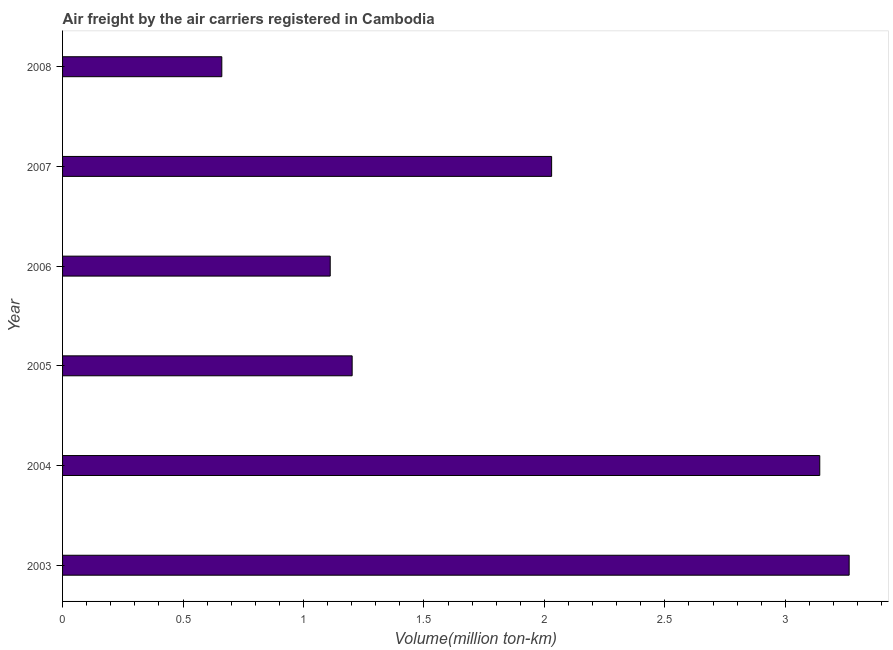Does the graph contain any zero values?
Offer a very short reply. No. What is the title of the graph?
Provide a succinct answer. Air freight by the air carriers registered in Cambodia. What is the label or title of the X-axis?
Give a very brief answer. Volume(million ton-km). What is the air freight in 2005?
Give a very brief answer. 1.2. Across all years, what is the maximum air freight?
Provide a succinct answer. 3.27. Across all years, what is the minimum air freight?
Provide a short and direct response. 0.66. In which year was the air freight maximum?
Provide a succinct answer. 2003. In which year was the air freight minimum?
Offer a terse response. 2008. What is the sum of the air freight?
Keep it short and to the point. 11.41. What is the difference between the air freight in 2003 and 2006?
Provide a short and direct response. 2.15. What is the average air freight per year?
Give a very brief answer. 1.9. What is the median air freight?
Give a very brief answer. 1.62. In how many years, is the air freight greater than 0.6 million ton-km?
Your answer should be compact. 6. Do a majority of the years between 2003 and 2006 (inclusive) have air freight greater than 0.8 million ton-km?
Your response must be concise. Yes. What is the ratio of the air freight in 2004 to that in 2005?
Give a very brief answer. 2.62. Is the air freight in 2003 less than that in 2008?
Your answer should be very brief. No. Is the difference between the air freight in 2003 and 2006 greater than the difference between any two years?
Your response must be concise. No. What is the difference between the highest and the second highest air freight?
Keep it short and to the point. 0.12. Are all the bars in the graph horizontal?
Give a very brief answer. Yes. How many years are there in the graph?
Your response must be concise. 6. What is the difference between two consecutive major ticks on the X-axis?
Provide a short and direct response. 0.5. Are the values on the major ticks of X-axis written in scientific E-notation?
Ensure brevity in your answer.  No. What is the Volume(million ton-km) in 2003?
Provide a succinct answer. 3.27. What is the Volume(million ton-km) of 2004?
Offer a very short reply. 3.14. What is the Volume(million ton-km) of 2005?
Provide a succinct answer. 1.2. What is the Volume(million ton-km) of 2006?
Give a very brief answer. 1.11. What is the Volume(million ton-km) in 2007?
Your response must be concise. 2.03. What is the Volume(million ton-km) of 2008?
Your answer should be very brief. 0.66. What is the difference between the Volume(million ton-km) in 2003 and 2004?
Make the answer very short. 0.12. What is the difference between the Volume(million ton-km) in 2003 and 2005?
Offer a very short reply. 2.06. What is the difference between the Volume(million ton-km) in 2003 and 2006?
Provide a succinct answer. 2.15. What is the difference between the Volume(million ton-km) in 2003 and 2007?
Offer a terse response. 1.24. What is the difference between the Volume(million ton-km) in 2003 and 2008?
Your answer should be very brief. 2.6. What is the difference between the Volume(million ton-km) in 2004 and 2005?
Your response must be concise. 1.94. What is the difference between the Volume(million ton-km) in 2004 and 2006?
Keep it short and to the point. 2.03. What is the difference between the Volume(million ton-km) in 2004 and 2007?
Make the answer very short. 1.11. What is the difference between the Volume(million ton-km) in 2004 and 2008?
Your answer should be compact. 2.48. What is the difference between the Volume(million ton-km) in 2005 and 2006?
Provide a short and direct response. 0.09. What is the difference between the Volume(million ton-km) in 2005 and 2007?
Offer a terse response. -0.83. What is the difference between the Volume(million ton-km) in 2005 and 2008?
Your answer should be compact. 0.54. What is the difference between the Volume(million ton-km) in 2006 and 2007?
Provide a short and direct response. -0.92. What is the difference between the Volume(million ton-km) in 2006 and 2008?
Make the answer very short. 0.45. What is the difference between the Volume(million ton-km) in 2007 and 2008?
Your answer should be very brief. 1.37. What is the ratio of the Volume(million ton-km) in 2003 to that in 2004?
Offer a terse response. 1.04. What is the ratio of the Volume(million ton-km) in 2003 to that in 2005?
Offer a very short reply. 2.72. What is the ratio of the Volume(million ton-km) in 2003 to that in 2006?
Your answer should be compact. 2.94. What is the ratio of the Volume(million ton-km) in 2003 to that in 2007?
Make the answer very short. 1.61. What is the ratio of the Volume(million ton-km) in 2003 to that in 2008?
Give a very brief answer. 4.94. What is the ratio of the Volume(million ton-km) in 2004 to that in 2005?
Make the answer very short. 2.62. What is the ratio of the Volume(million ton-km) in 2004 to that in 2006?
Ensure brevity in your answer.  2.83. What is the ratio of the Volume(million ton-km) in 2004 to that in 2007?
Your answer should be very brief. 1.55. What is the ratio of the Volume(million ton-km) in 2004 to that in 2008?
Your response must be concise. 4.75. What is the ratio of the Volume(million ton-km) in 2005 to that in 2006?
Ensure brevity in your answer.  1.08. What is the ratio of the Volume(million ton-km) in 2005 to that in 2007?
Provide a short and direct response. 0.59. What is the ratio of the Volume(million ton-km) in 2005 to that in 2008?
Give a very brief answer. 1.82. What is the ratio of the Volume(million ton-km) in 2006 to that in 2007?
Make the answer very short. 0.55. What is the ratio of the Volume(million ton-km) in 2006 to that in 2008?
Your response must be concise. 1.68. What is the ratio of the Volume(million ton-km) in 2007 to that in 2008?
Give a very brief answer. 3.07. 